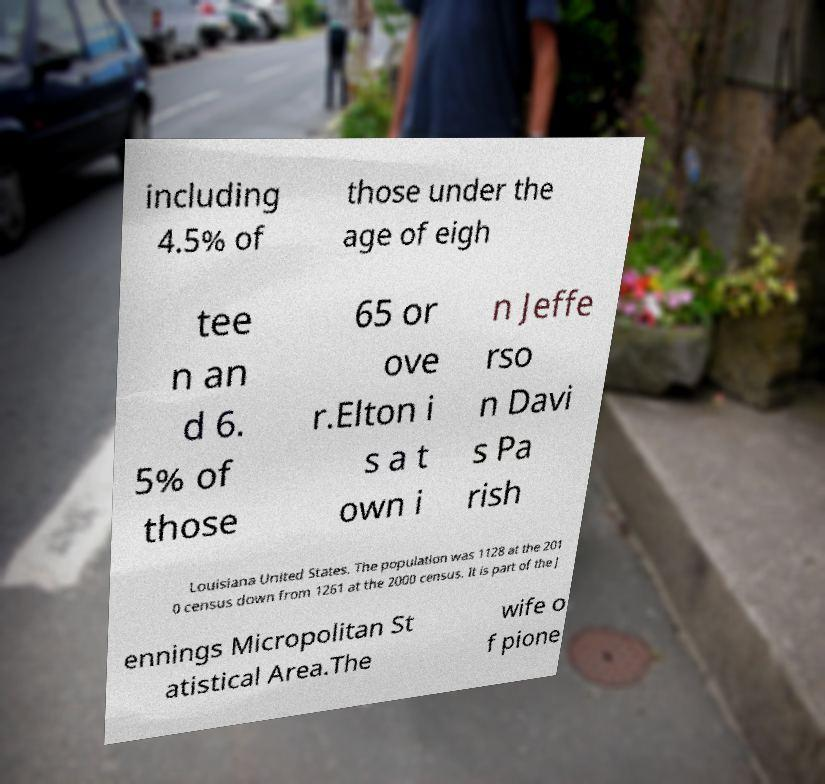Please identify and transcribe the text found in this image. including 4.5% of those under the age of eigh tee n an d 6. 5% of those 65 or ove r.Elton i s a t own i n Jeffe rso n Davi s Pa rish Louisiana United States. The population was 1128 at the 201 0 census down from 1261 at the 2000 census. It is part of the J ennings Micropolitan St atistical Area.The wife o f pione 